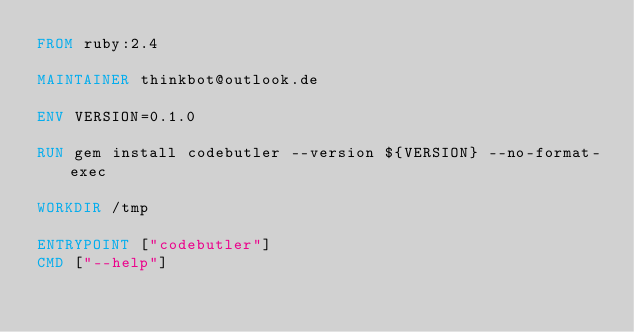<code> <loc_0><loc_0><loc_500><loc_500><_Dockerfile_>FROM ruby:2.4

MAINTAINER thinkbot@outlook.de

ENV VERSION=0.1.0

RUN gem install codebutler --version ${VERSION} --no-format-exec

WORKDIR /tmp

ENTRYPOINT ["codebutler"]
CMD ["--help"]
</code> 